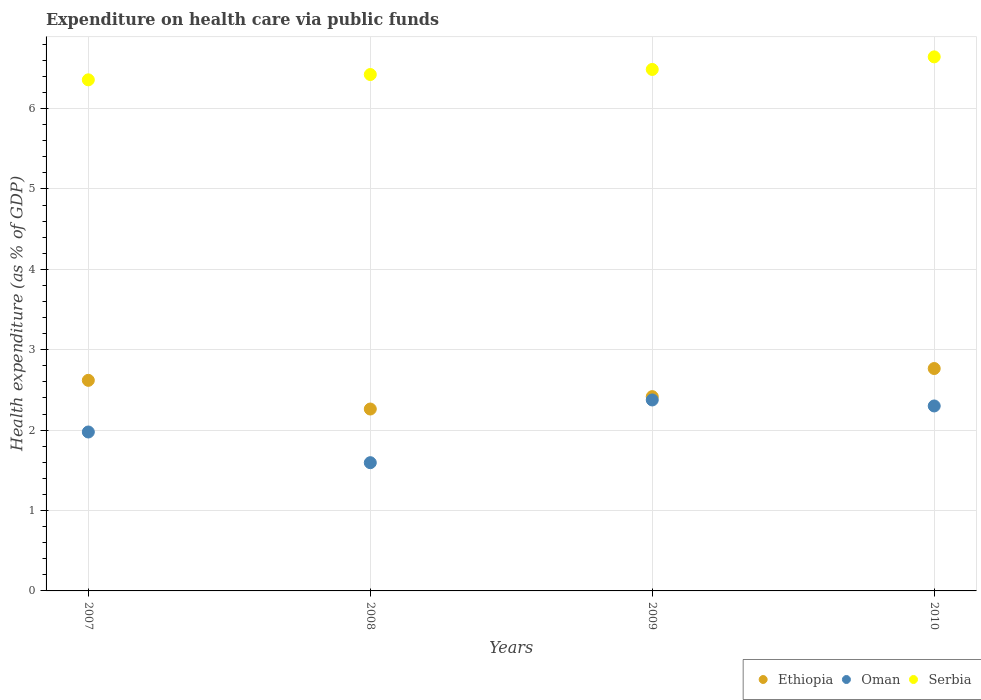How many different coloured dotlines are there?
Offer a very short reply. 3. Is the number of dotlines equal to the number of legend labels?
Give a very brief answer. Yes. What is the expenditure made on health care in Oman in 2008?
Your answer should be compact. 1.6. Across all years, what is the maximum expenditure made on health care in Serbia?
Give a very brief answer. 6.64. Across all years, what is the minimum expenditure made on health care in Serbia?
Offer a terse response. 6.36. In which year was the expenditure made on health care in Serbia maximum?
Make the answer very short. 2010. What is the total expenditure made on health care in Ethiopia in the graph?
Ensure brevity in your answer.  10.07. What is the difference between the expenditure made on health care in Ethiopia in 2007 and that in 2010?
Ensure brevity in your answer.  -0.15. What is the difference between the expenditure made on health care in Serbia in 2009 and the expenditure made on health care in Ethiopia in 2008?
Your response must be concise. 4.22. What is the average expenditure made on health care in Ethiopia per year?
Offer a terse response. 2.52. In the year 2010, what is the difference between the expenditure made on health care in Ethiopia and expenditure made on health care in Serbia?
Make the answer very short. -3.88. In how many years, is the expenditure made on health care in Oman greater than 5.2 %?
Provide a succinct answer. 0. What is the ratio of the expenditure made on health care in Serbia in 2008 to that in 2010?
Offer a very short reply. 0.97. Is the expenditure made on health care in Ethiopia in 2007 less than that in 2008?
Provide a short and direct response. No. Is the difference between the expenditure made on health care in Ethiopia in 2007 and 2009 greater than the difference between the expenditure made on health care in Serbia in 2007 and 2009?
Your answer should be compact. Yes. What is the difference between the highest and the second highest expenditure made on health care in Serbia?
Give a very brief answer. 0.16. What is the difference between the highest and the lowest expenditure made on health care in Serbia?
Ensure brevity in your answer.  0.29. In how many years, is the expenditure made on health care in Oman greater than the average expenditure made on health care in Oman taken over all years?
Your answer should be very brief. 2. Is it the case that in every year, the sum of the expenditure made on health care in Oman and expenditure made on health care in Serbia  is greater than the expenditure made on health care in Ethiopia?
Provide a succinct answer. Yes. Is the expenditure made on health care in Serbia strictly less than the expenditure made on health care in Ethiopia over the years?
Ensure brevity in your answer.  No. What is the difference between two consecutive major ticks on the Y-axis?
Your answer should be very brief. 1. What is the title of the graph?
Offer a very short reply. Expenditure on health care via public funds. Does "Moldova" appear as one of the legend labels in the graph?
Offer a terse response. No. What is the label or title of the X-axis?
Offer a terse response. Years. What is the label or title of the Y-axis?
Provide a succinct answer. Health expenditure (as % of GDP). What is the Health expenditure (as % of GDP) of Ethiopia in 2007?
Ensure brevity in your answer.  2.62. What is the Health expenditure (as % of GDP) in Oman in 2007?
Keep it short and to the point. 1.98. What is the Health expenditure (as % of GDP) in Serbia in 2007?
Offer a terse response. 6.36. What is the Health expenditure (as % of GDP) of Ethiopia in 2008?
Your answer should be very brief. 2.26. What is the Health expenditure (as % of GDP) in Oman in 2008?
Provide a short and direct response. 1.6. What is the Health expenditure (as % of GDP) of Serbia in 2008?
Offer a very short reply. 6.42. What is the Health expenditure (as % of GDP) in Ethiopia in 2009?
Your response must be concise. 2.42. What is the Health expenditure (as % of GDP) in Oman in 2009?
Provide a succinct answer. 2.38. What is the Health expenditure (as % of GDP) of Serbia in 2009?
Your answer should be compact. 6.49. What is the Health expenditure (as % of GDP) in Ethiopia in 2010?
Offer a very short reply. 2.77. What is the Health expenditure (as % of GDP) in Oman in 2010?
Provide a short and direct response. 2.3. What is the Health expenditure (as % of GDP) of Serbia in 2010?
Offer a very short reply. 6.64. Across all years, what is the maximum Health expenditure (as % of GDP) of Ethiopia?
Ensure brevity in your answer.  2.77. Across all years, what is the maximum Health expenditure (as % of GDP) in Oman?
Your response must be concise. 2.38. Across all years, what is the maximum Health expenditure (as % of GDP) of Serbia?
Provide a short and direct response. 6.64. Across all years, what is the minimum Health expenditure (as % of GDP) of Ethiopia?
Keep it short and to the point. 2.26. Across all years, what is the minimum Health expenditure (as % of GDP) of Oman?
Ensure brevity in your answer.  1.6. Across all years, what is the minimum Health expenditure (as % of GDP) in Serbia?
Your response must be concise. 6.36. What is the total Health expenditure (as % of GDP) in Ethiopia in the graph?
Give a very brief answer. 10.07. What is the total Health expenditure (as % of GDP) in Oman in the graph?
Provide a short and direct response. 8.25. What is the total Health expenditure (as % of GDP) of Serbia in the graph?
Give a very brief answer. 25.91. What is the difference between the Health expenditure (as % of GDP) of Ethiopia in 2007 and that in 2008?
Your answer should be very brief. 0.36. What is the difference between the Health expenditure (as % of GDP) of Oman in 2007 and that in 2008?
Provide a succinct answer. 0.38. What is the difference between the Health expenditure (as % of GDP) of Serbia in 2007 and that in 2008?
Offer a terse response. -0.07. What is the difference between the Health expenditure (as % of GDP) in Ethiopia in 2007 and that in 2009?
Give a very brief answer. 0.2. What is the difference between the Health expenditure (as % of GDP) in Oman in 2007 and that in 2009?
Your answer should be very brief. -0.4. What is the difference between the Health expenditure (as % of GDP) in Serbia in 2007 and that in 2009?
Your answer should be very brief. -0.13. What is the difference between the Health expenditure (as % of GDP) of Ethiopia in 2007 and that in 2010?
Give a very brief answer. -0.15. What is the difference between the Health expenditure (as % of GDP) in Oman in 2007 and that in 2010?
Provide a succinct answer. -0.32. What is the difference between the Health expenditure (as % of GDP) in Serbia in 2007 and that in 2010?
Your response must be concise. -0.29. What is the difference between the Health expenditure (as % of GDP) in Ethiopia in 2008 and that in 2009?
Make the answer very short. -0.15. What is the difference between the Health expenditure (as % of GDP) in Oman in 2008 and that in 2009?
Make the answer very short. -0.78. What is the difference between the Health expenditure (as % of GDP) in Serbia in 2008 and that in 2009?
Offer a terse response. -0.06. What is the difference between the Health expenditure (as % of GDP) in Ethiopia in 2008 and that in 2010?
Provide a succinct answer. -0.5. What is the difference between the Health expenditure (as % of GDP) in Oman in 2008 and that in 2010?
Make the answer very short. -0.71. What is the difference between the Health expenditure (as % of GDP) in Serbia in 2008 and that in 2010?
Give a very brief answer. -0.22. What is the difference between the Health expenditure (as % of GDP) in Ethiopia in 2009 and that in 2010?
Offer a very short reply. -0.35. What is the difference between the Health expenditure (as % of GDP) of Oman in 2009 and that in 2010?
Your answer should be compact. 0.07. What is the difference between the Health expenditure (as % of GDP) in Serbia in 2009 and that in 2010?
Your answer should be compact. -0.16. What is the difference between the Health expenditure (as % of GDP) in Ethiopia in 2007 and the Health expenditure (as % of GDP) in Oman in 2008?
Keep it short and to the point. 1.02. What is the difference between the Health expenditure (as % of GDP) in Ethiopia in 2007 and the Health expenditure (as % of GDP) in Serbia in 2008?
Ensure brevity in your answer.  -3.8. What is the difference between the Health expenditure (as % of GDP) in Oman in 2007 and the Health expenditure (as % of GDP) in Serbia in 2008?
Make the answer very short. -4.45. What is the difference between the Health expenditure (as % of GDP) of Ethiopia in 2007 and the Health expenditure (as % of GDP) of Oman in 2009?
Your answer should be compact. 0.24. What is the difference between the Health expenditure (as % of GDP) in Ethiopia in 2007 and the Health expenditure (as % of GDP) in Serbia in 2009?
Provide a succinct answer. -3.87. What is the difference between the Health expenditure (as % of GDP) in Oman in 2007 and the Health expenditure (as % of GDP) in Serbia in 2009?
Offer a terse response. -4.51. What is the difference between the Health expenditure (as % of GDP) in Ethiopia in 2007 and the Health expenditure (as % of GDP) in Oman in 2010?
Your response must be concise. 0.32. What is the difference between the Health expenditure (as % of GDP) of Ethiopia in 2007 and the Health expenditure (as % of GDP) of Serbia in 2010?
Offer a very short reply. -4.02. What is the difference between the Health expenditure (as % of GDP) of Oman in 2007 and the Health expenditure (as % of GDP) of Serbia in 2010?
Offer a very short reply. -4.67. What is the difference between the Health expenditure (as % of GDP) of Ethiopia in 2008 and the Health expenditure (as % of GDP) of Oman in 2009?
Keep it short and to the point. -0.11. What is the difference between the Health expenditure (as % of GDP) of Ethiopia in 2008 and the Health expenditure (as % of GDP) of Serbia in 2009?
Your answer should be compact. -4.22. What is the difference between the Health expenditure (as % of GDP) of Oman in 2008 and the Health expenditure (as % of GDP) of Serbia in 2009?
Keep it short and to the point. -4.89. What is the difference between the Health expenditure (as % of GDP) of Ethiopia in 2008 and the Health expenditure (as % of GDP) of Oman in 2010?
Provide a succinct answer. -0.04. What is the difference between the Health expenditure (as % of GDP) of Ethiopia in 2008 and the Health expenditure (as % of GDP) of Serbia in 2010?
Offer a terse response. -4.38. What is the difference between the Health expenditure (as % of GDP) of Oman in 2008 and the Health expenditure (as % of GDP) of Serbia in 2010?
Offer a terse response. -5.05. What is the difference between the Health expenditure (as % of GDP) of Ethiopia in 2009 and the Health expenditure (as % of GDP) of Oman in 2010?
Provide a short and direct response. 0.12. What is the difference between the Health expenditure (as % of GDP) in Ethiopia in 2009 and the Health expenditure (as % of GDP) in Serbia in 2010?
Provide a succinct answer. -4.23. What is the difference between the Health expenditure (as % of GDP) of Oman in 2009 and the Health expenditure (as % of GDP) of Serbia in 2010?
Provide a succinct answer. -4.27. What is the average Health expenditure (as % of GDP) in Ethiopia per year?
Make the answer very short. 2.52. What is the average Health expenditure (as % of GDP) of Oman per year?
Provide a short and direct response. 2.06. What is the average Health expenditure (as % of GDP) of Serbia per year?
Your answer should be very brief. 6.48. In the year 2007, what is the difference between the Health expenditure (as % of GDP) of Ethiopia and Health expenditure (as % of GDP) of Oman?
Ensure brevity in your answer.  0.64. In the year 2007, what is the difference between the Health expenditure (as % of GDP) in Ethiopia and Health expenditure (as % of GDP) in Serbia?
Your response must be concise. -3.74. In the year 2007, what is the difference between the Health expenditure (as % of GDP) in Oman and Health expenditure (as % of GDP) in Serbia?
Keep it short and to the point. -4.38. In the year 2008, what is the difference between the Health expenditure (as % of GDP) in Ethiopia and Health expenditure (as % of GDP) in Oman?
Offer a terse response. 0.67. In the year 2008, what is the difference between the Health expenditure (as % of GDP) of Ethiopia and Health expenditure (as % of GDP) of Serbia?
Ensure brevity in your answer.  -4.16. In the year 2008, what is the difference between the Health expenditure (as % of GDP) in Oman and Health expenditure (as % of GDP) in Serbia?
Make the answer very short. -4.83. In the year 2009, what is the difference between the Health expenditure (as % of GDP) in Ethiopia and Health expenditure (as % of GDP) in Oman?
Ensure brevity in your answer.  0.04. In the year 2009, what is the difference between the Health expenditure (as % of GDP) of Ethiopia and Health expenditure (as % of GDP) of Serbia?
Provide a succinct answer. -4.07. In the year 2009, what is the difference between the Health expenditure (as % of GDP) of Oman and Health expenditure (as % of GDP) of Serbia?
Provide a succinct answer. -4.11. In the year 2010, what is the difference between the Health expenditure (as % of GDP) of Ethiopia and Health expenditure (as % of GDP) of Oman?
Keep it short and to the point. 0.47. In the year 2010, what is the difference between the Health expenditure (as % of GDP) in Ethiopia and Health expenditure (as % of GDP) in Serbia?
Provide a succinct answer. -3.88. In the year 2010, what is the difference between the Health expenditure (as % of GDP) in Oman and Health expenditure (as % of GDP) in Serbia?
Make the answer very short. -4.34. What is the ratio of the Health expenditure (as % of GDP) in Ethiopia in 2007 to that in 2008?
Offer a terse response. 1.16. What is the ratio of the Health expenditure (as % of GDP) in Oman in 2007 to that in 2008?
Offer a terse response. 1.24. What is the ratio of the Health expenditure (as % of GDP) of Serbia in 2007 to that in 2008?
Your response must be concise. 0.99. What is the ratio of the Health expenditure (as % of GDP) in Ethiopia in 2007 to that in 2009?
Provide a short and direct response. 1.08. What is the ratio of the Health expenditure (as % of GDP) in Oman in 2007 to that in 2009?
Keep it short and to the point. 0.83. What is the ratio of the Health expenditure (as % of GDP) of Serbia in 2007 to that in 2009?
Provide a succinct answer. 0.98. What is the ratio of the Health expenditure (as % of GDP) of Ethiopia in 2007 to that in 2010?
Your response must be concise. 0.95. What is the ratio of the Health expenditure (as % of GDP) of Oman in 2007 to that in 2010?
Your response must be concise. 0.86. What is the ratio of the Health expenditure (as % of GDP) in Serbia in 2007 to that in 2010?
Ensure brevity in your answer.  0.96. What is the ratio of the Health expenditure (as % of GDP) of Ethiopia in 2008 to that in 2009?
Ensure brevity in your answer.  0.94. What is the ratio of the Health expenditure (as % of GDP) in Oman in 2008 to that in 2009?
Provide a succinct answer. 0.67. What is the ratio of the Health expenditure (as % of GDP) of Serbia in 2008 to that in 2009?
Give a very brief answer. 0.99. What is the ratio of the Health expenditure (as % of GDP) in Ethiopia in 2008 to that in 2010?
Offer a terse response. 0.82. What is the ratio of the Health expenditure (as % of GDP) in Oman in 2008 to that in 2010?
Provide a short and direct response. 0.69. What is the ratio of the Health expenditure (as % of GDP) of Serbia in 2008 to that in 2010?
Offer a terse response. 0.97. What is the ratio of the Health expenditure (as % of GDP) of Ethiopia in 2009 to that in 2010?
Ensure brevity in your answer.  0.87. What is the ratio of the Health expenditure (as % of GDP) in Oman in 2009 to that in 2010?
Offer a terse response. 1.03. What is the ratio of the Health expenditure (as % of GDP) of Serbia in 2009 to that in 2010?
Provide a short and direct response. 0.98. What is the difference between the highest and the second highest Health expenditure (as % of GDP) of Ethiopia?
Offer a very short reply. 0.15. What is the difference between the highest and the second highest Health expenditure (as % of GDP) of Oman?
Your answer should be very brief. 0.07. What is the difference between the highest and the second highest Health expenditure (as % of GDP) in Serbia?
Offer a terse response. 0.16. What is the difference between the highest and the lowest Health expenditure (as % of GDP) of Ethiopia?
Ensure brevity in your answer.  0.5. What is the difference between the highest and the lowest Health expenditure (as % of GDP) in Oman?
Give a very brief answer. 0.78. What is the difference between the highest and the lowest Health expenditure (as % of GDP) of Serbia?
Offer a terse response. 0.29. 